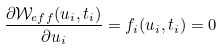Convert formula to latex. <formula><loc_0><loc_0><loc_500><loc_500>\frac { \partial \mathcal { W } _ { e f f } ( u _ { i } , t _ { i } ) } { \partial u _ { i } } & = f _ { i } ( u _ { i } , t _ { i } ) = 0</formula> 